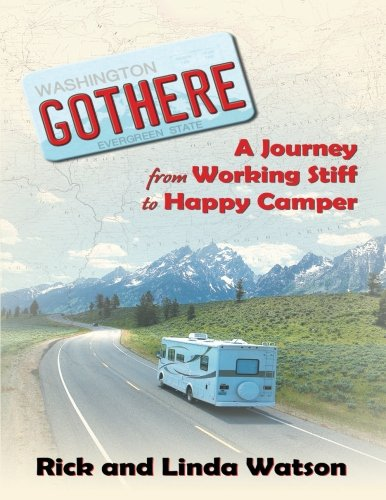Who is the author of this book? The book is authored by Rick Watson and Linda Watson, as indicated by the names on the cover. 